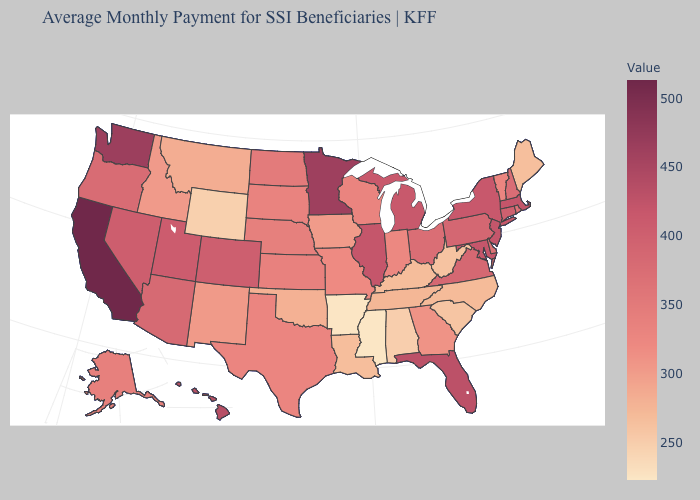Does Mississippi have the lowest value in the USA?
Keep it brief. Yes. Among the states that border Florida , which have the highest value?
Write a very short answer. Georgia. Which states have the highest value in the USA?
Answer briefly. California. Which states have the highest value in the USA?
Write a very short answer. California. 